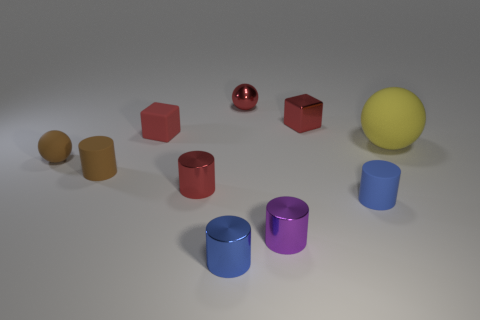Do the small metal cube and the metal ball have the same color?
Offer a very short reply. Yes. How many things are red cubes to the left of the purple cylinder or tiny things that are left of the blue metallic thing?
Your response must be concise. 4. Are there fewer small matte cylinders that are to the right of the small blue matte thing than big gray matte objects?
Provide a short and direct response. No. Is the material of the large yellow ball the same as the tiny ball to the right of the small brown matte cylinder?
Provide a succinct answer. No. What material is the small purple cylinder?
Provide a short and direct response. Metal. What material is the tiny sphere that is left of the tiny red block that is to the left of the small blue cylinder left of the small metallic sphere made of?
Your answer should be very brief. Rubber. There is a small shiny block; does it have the same color as the ball behind the tiny rubber block?
Your answer should be very brief. Yes. What color is the matte object in front of the brown object that is in front of the small brown rubber sphere?
Your answer should be very brief. Blue. What number of large gray spheres are there?
Keep it short and to the point. 0. What number of matte things are blue cylinders or tiny balls?
Your answer should be very brief. 2. 